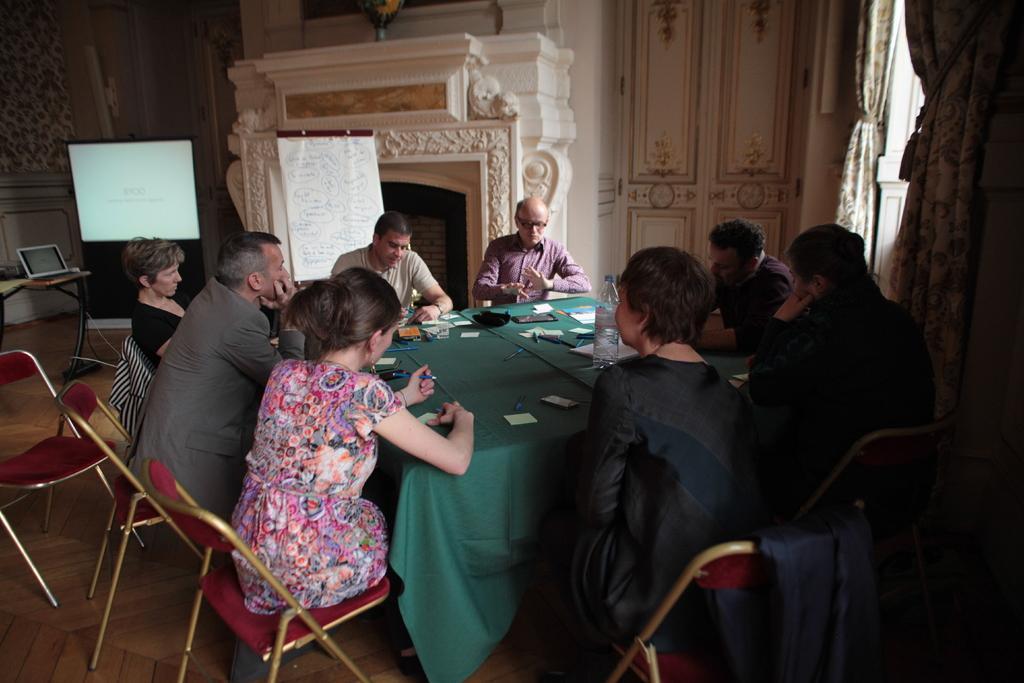Could you give a brief overview of what you see in this image? In the image we can see there are people who are sitting on chair. 